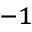Convert formula to latex. <formula><loc_0><loc_0><loc_500><loc_500>^ { - 1 }</formula> 